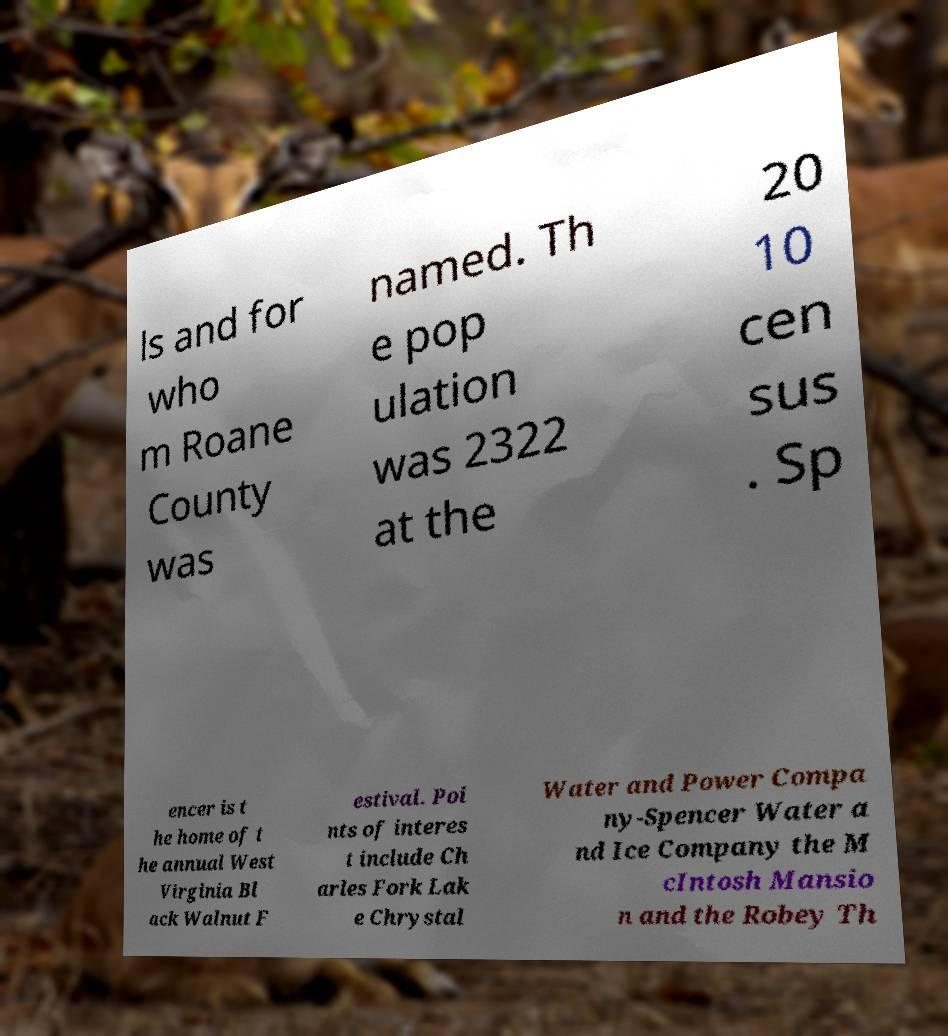Can you accurately transcribe the text from the provided image for me? ls and for who m Roane County was named. Th e pop ulation was 2322 at the 20 10 cen sus . Sp encer is t he home of t he annual West Virginia Bl ack Walnut F estival. Poi nts of interes t include Ch arles Fork Lak e Chrystal Water and Power Compa ny-Spencer Water a nd Ice Company the M cIntosh Mansio n and the Robey Th 